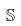Convert formula to latex. <formula><loc_0><loc_0><loc_500><loc_500>\mathbb { S }</formula> 